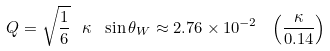<formula> <loc_0><loc_0><loc_500><loc_500>Q = \sqrt { \frac { 1 } { 6 } } \ \kappa \ \sin \theta _ { W } \approx 2 . 7 6 \times 1 0 ^ { - 2 } \ \left ( \frac { \kappa } { 0 . 1 4 } \right )</formula> 